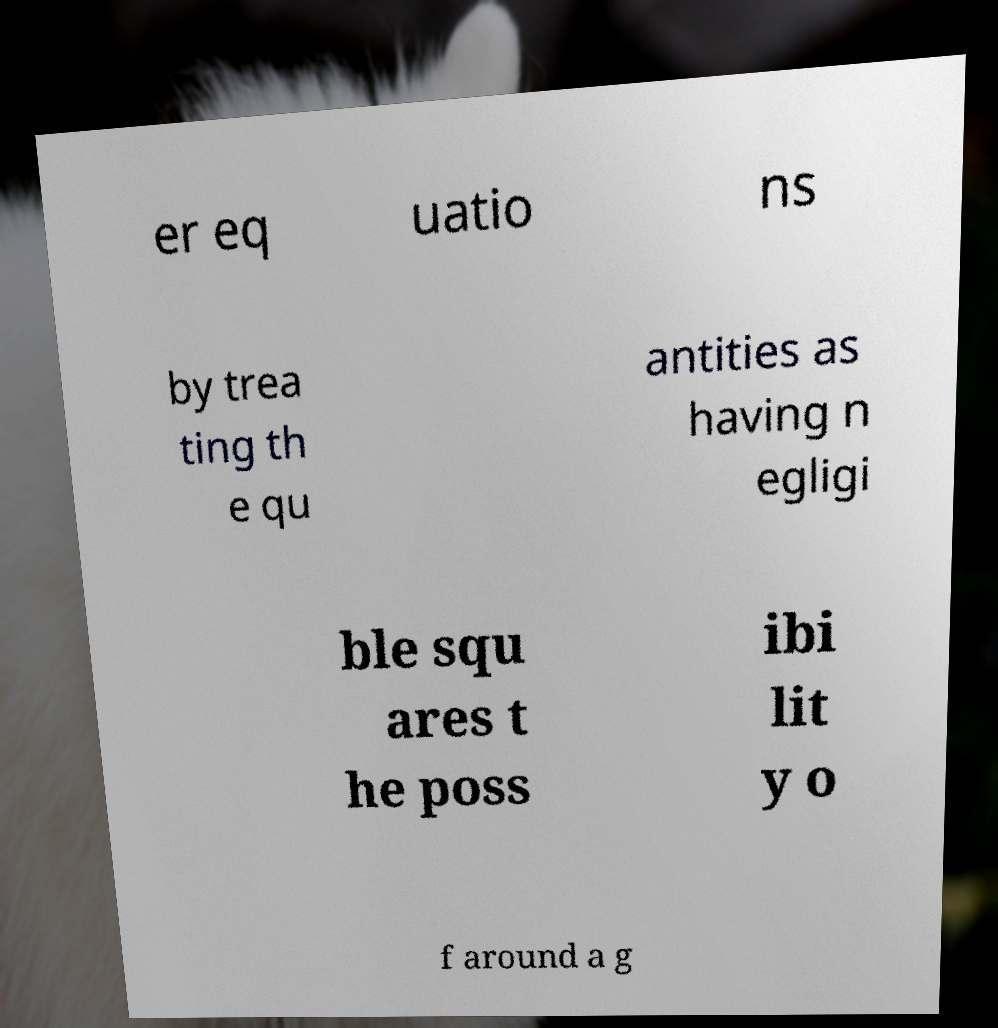Please read and relay the text visible in this image. What does it say? er eq uatio ns by trea ting th e qu antities as having n egligi ble squ ares t he poss ibi lit y o f around a g 